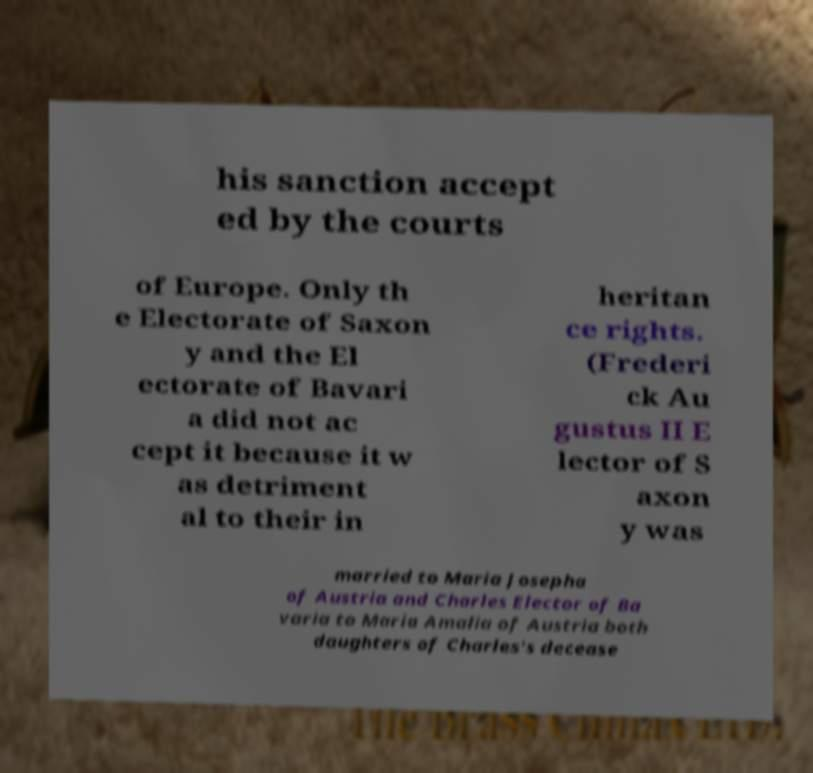For documentation purposes, I need the text within this image transcribed. Could you provide that? his sanction accept ed by the courts of Europe. Only th e Electorate of Saxon y and the El ectorate of Bavari a did not ac cept it because it w as detriment al to their in heritan ce rights. (Frederi ck Au gustus II E lector of S axon y was married to Maria Josepha of Austria and Charles Elector of Ba varia to Maria Amalia of Austria both daughters of Charles's decease 